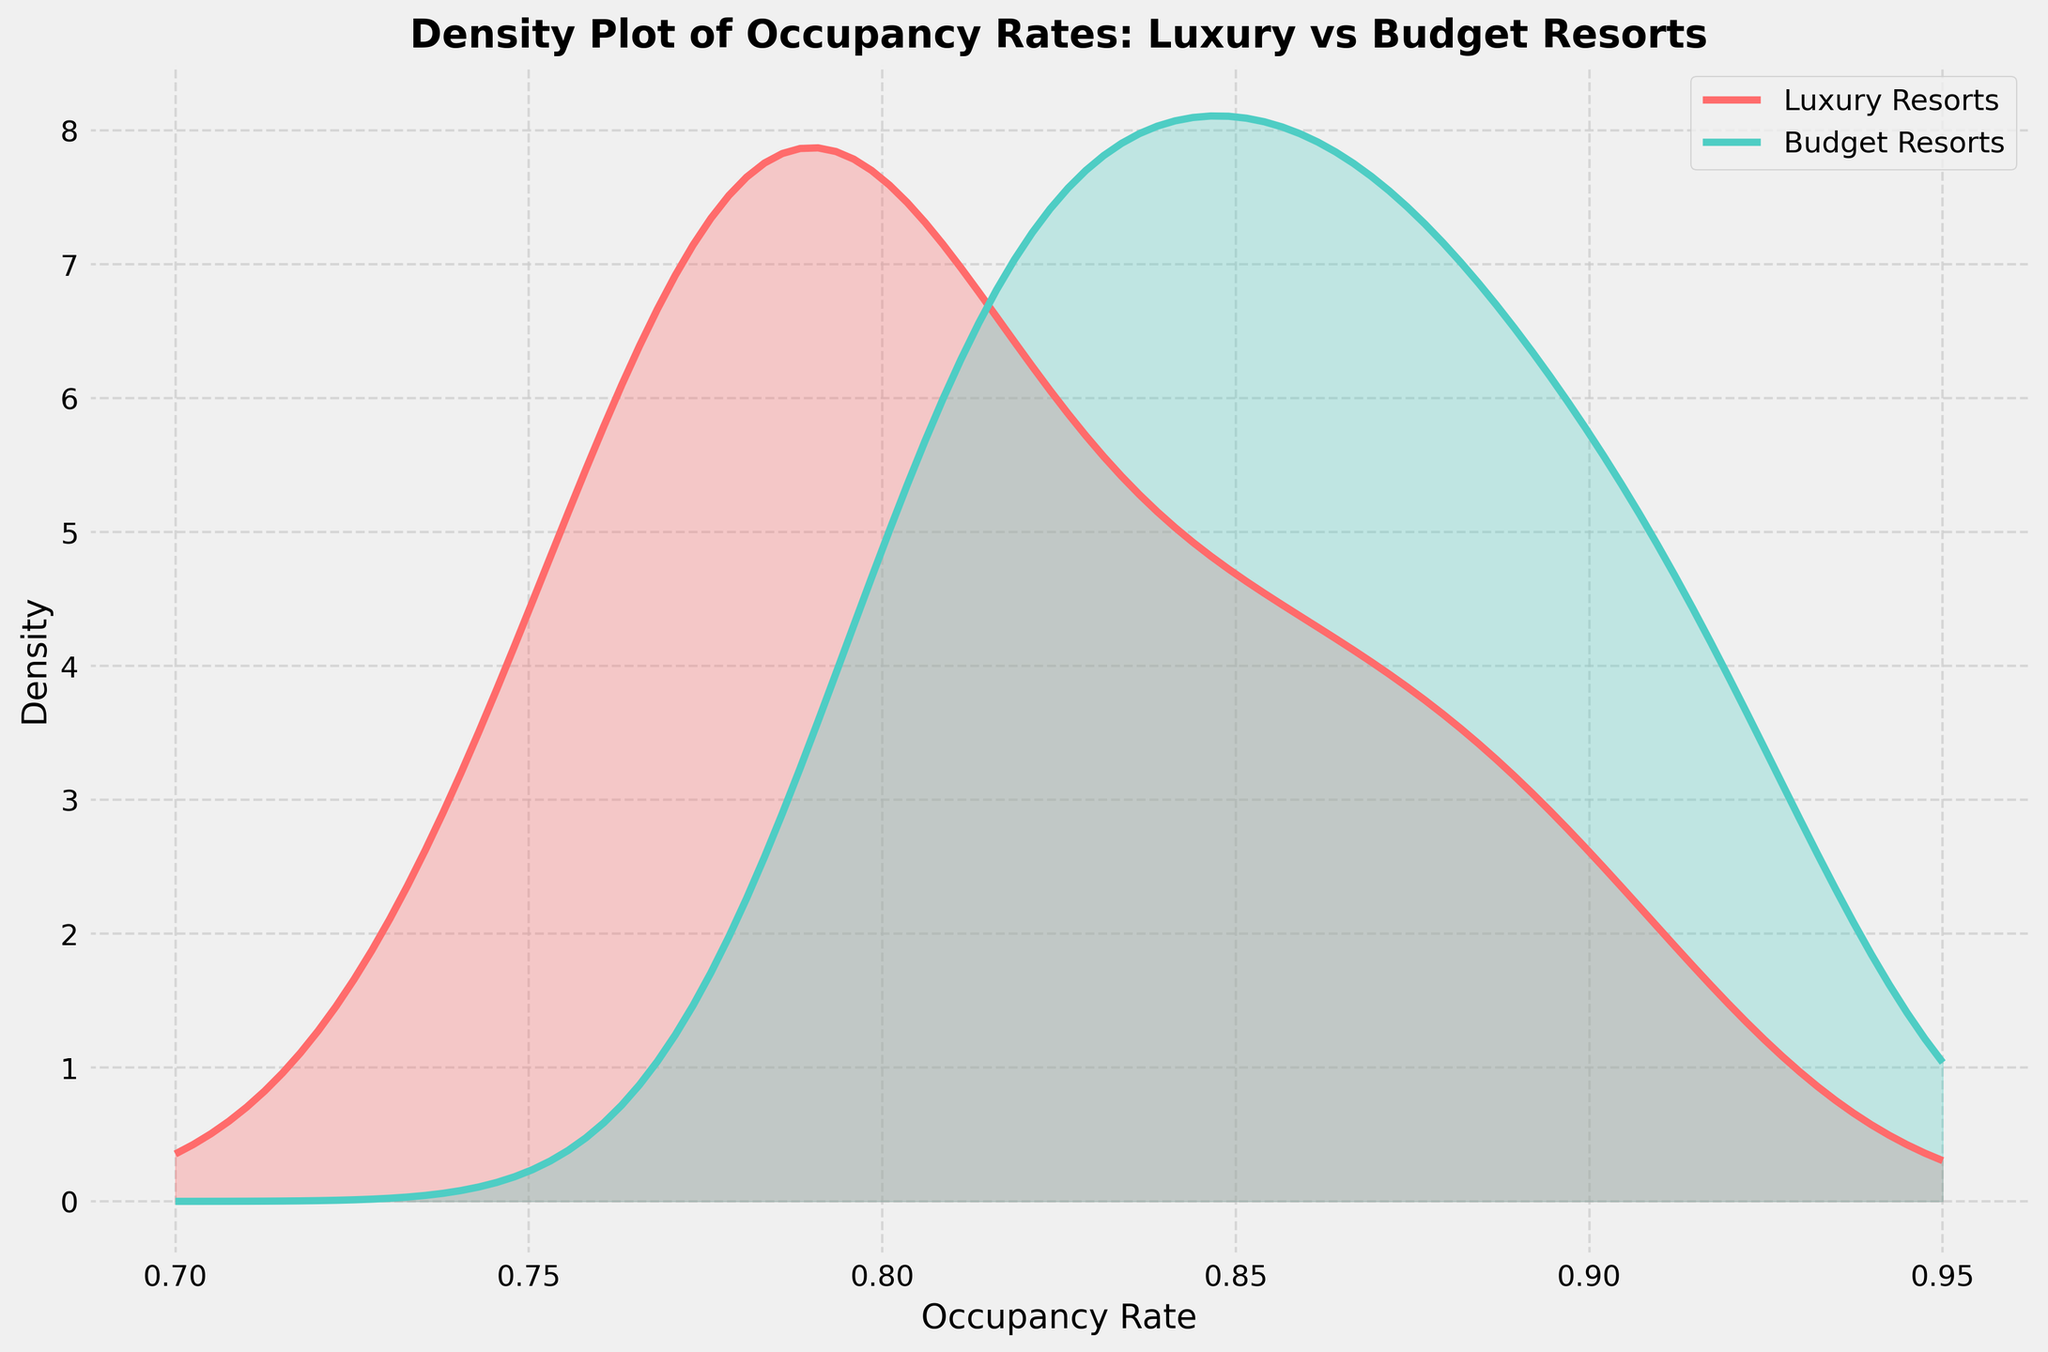What is the title of the figure? The title is Text shown at the top of the plot that describes the purpose of the figure.
Answer: Density Plot of Occupancy Rates: Luxury vs Budget Resorts Which line represents luxury resorts? Luxury resorts are shown by the solid red line (Luxurious color).
Answer: The red line What is the x-axis labeled as? The x-axis represents the monthly occupancy rate.
Answer: Occupancy Rate Which resort type shows a higher density at an occupancy rate of around 0.85? By observing the height of the curves at the 0.85 mark on the x-axis, the blue curve (Budget Resorts) shows a higher density compared to the red curve (Luxury Resorts).
Answer: Budget Resorts Which resort type has a higher peak in their density curve? Observing the height of both density curves, the blue curve (Budget Resorts) reaches a higher peak than the red curve (Luxury Resorts).
Answer: Budget Resorts What is the range of occupancy rates shown on the x-axis? The x-axis starts at 0.7 and ends at 0.95, covering the range of monthly occupancy rates depicted in the figure.
Answer: From 0.7 to 0.95 How does the spread of the occupancy rates for luxury resorts compare to budget resorts? The spread of a density plot is often indicated by the width of the curve; the red curve (Luxury Resorts) is somewhat narrower compared to the blue curve (Budget Resorts), suggesting a tighter concentration of data points around central values.
Answer: Narrower At what occupancy rate do luxury resorts exhibit their highest density? The peak of the red curve, representing luxury resorts, occurs approximately at an occupancy rate of 0.85.
Answer: Around 0.85 Which resort type exhibits greater variability in their occupancy rates? Variability is indicated by the width and spread of the density curve; the blue curve (Budget Resorts) is more spread out, indicating greater variability in occupancy rates compared to the red curve (Luxury Resorts).
Answer: Budget Resorts What can be inferred about the highest density of budget resorts' occupancy rate compared to their lowest density rate? The peak of the blue curve for Budget Resorts shows a much higher density compared to lower points, suggesting that a significant number of observations are concentrated around the peak value.
Answer: Most observations are around peak value 